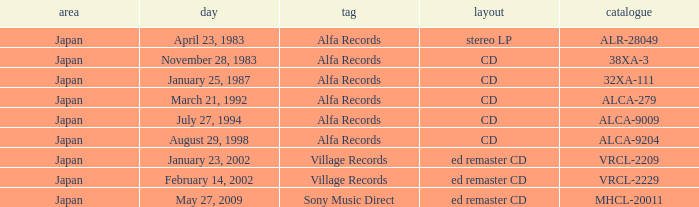In the catalog, which area is referred to as 38xa-3? Japan. 